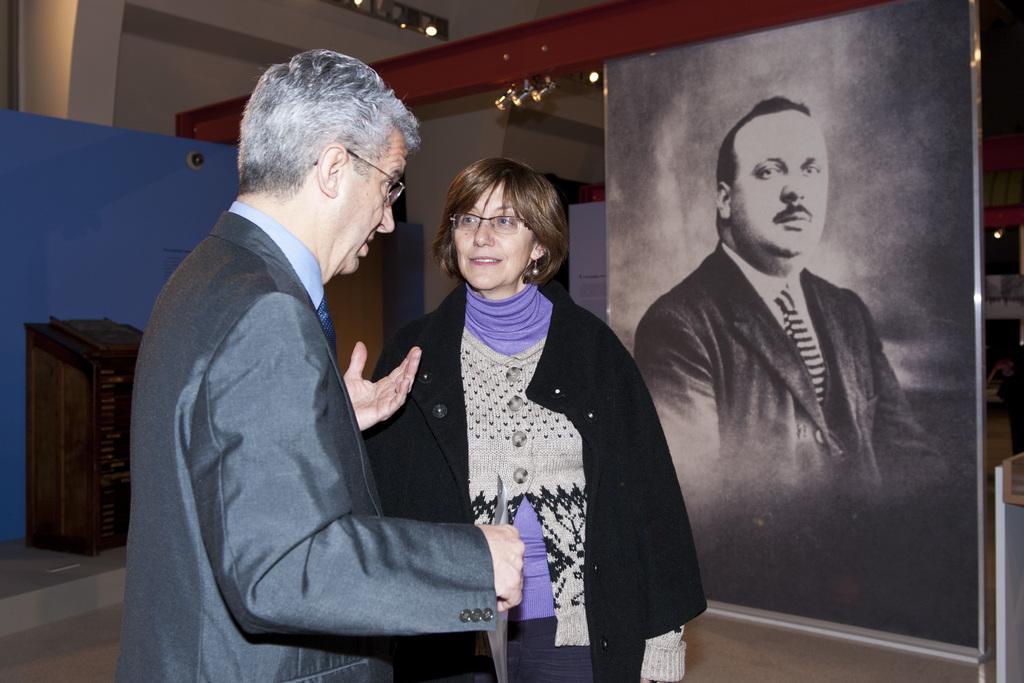Describe this image in one or two sentences. There is a person wearing suit is standing and speaking and there is a woman standing beside him and there is a picture of a person in the right corner. 